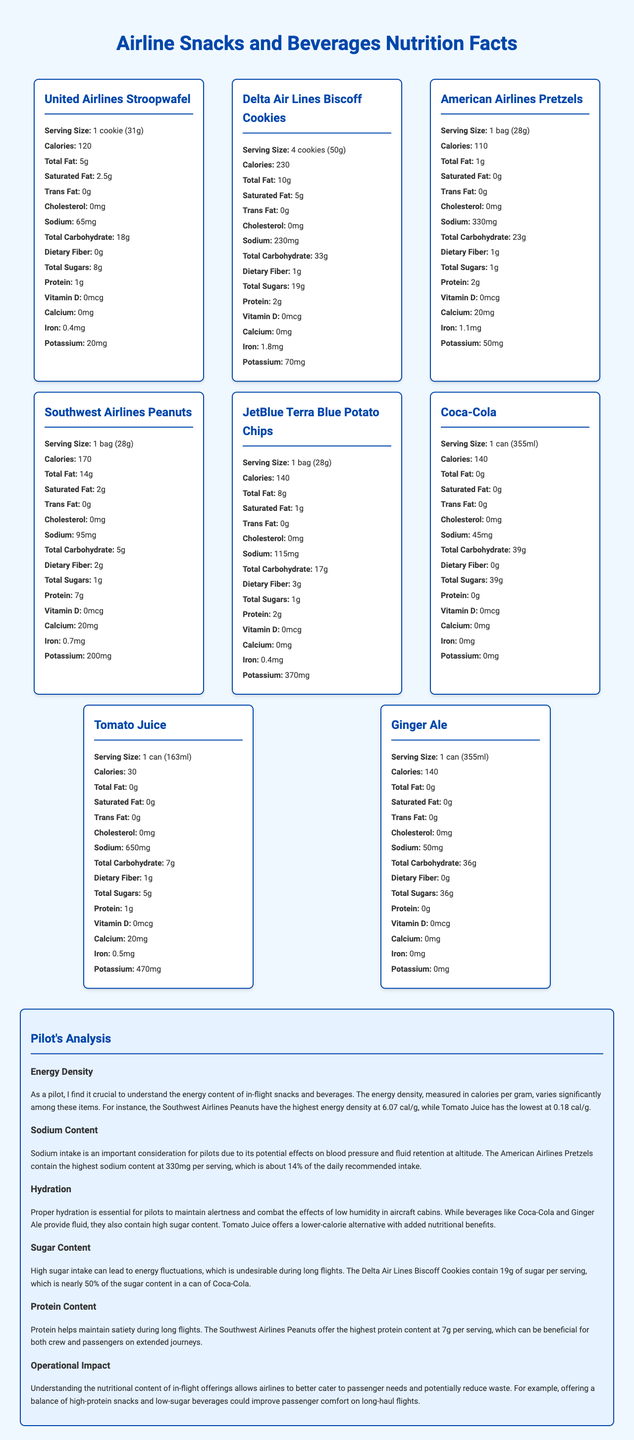what is the serving size for United Airlines Stroopwafel? The document clearly states that the serving size for the United Airlines Stroopwafel is 1 cookie (31g).
Answer: 1 cookie (31g) how many calories are in a serving of Delta Air Lines Biscoff Cookies? The document shows that Delta Air Lines Biscoff Cookies contain 230 calories per serving.
Answer: 230 calories which item has the highest sodium content? The nutritional information shows that American Airlines Pretzels have the highest sodium content at 330mg per serving.
Answer: American Airlines Pretzels what is the total fat content in a serving of Southwest Airlines Peanuts? The document indicates that Southwest Airlines Peanuts have 14g of total fat per serving.
Answer: 14g which snack has the lowest calorie content per serving? The document lists Tomato Juice as having the lowest calorie content per serving at 30 calories.
Answer: Tomato Juice which snack or beverage has the highest protein content? A. Delta Air Lines Biscoff Cookies B. Southwest Airlines Peanuts C. JetBlue Terra Blue Potato Chips D. Coca-Cola The Southwest Airlines Peanuts have the highest protein content at 7g per serving.
Answer: B which beverage has the highest sugar content? A. Coca-Cola B. Tomato Juice C. Ginger Ale Coca-Cola has the highest sugar content with 39g per serving.
Answer: A do United Airlines Stroopwafels contain any trans fat? The document states that United Airlines Stroopwafels contain 0g of trans fat.
Answer: No summarize the main idea of the document. The document extensively elaborates on the nutritional facts of airline snack and beverage offerings and includes a pilot's perspective on how these nutritional values can impact flight performance and passenger experience.
Answer: The document provides a detailed comparison of the nutritional content of various snacks and beverages offered by different airlines. It includes information about serving size, calories, total fat, sugars, sodium, protein, and other nutrients for each item. Additionally, there is an analysis by a pilot highlighting key points like energy density, sodium content, hydration benefits, sugar content, protein content, and operational impact. how much potassium is in a serving of JetBlue Terra Blue Potato Chips? The document states that JetBlue Terra Blue Potato Chips contain 370mg of potassium per serving.
Answer: 370mg can you determine the fiber content of Coca-Cola from the document? The document does not provide any information about the dietary fiber content in Coca-Cola.
Answer: Not enough information 